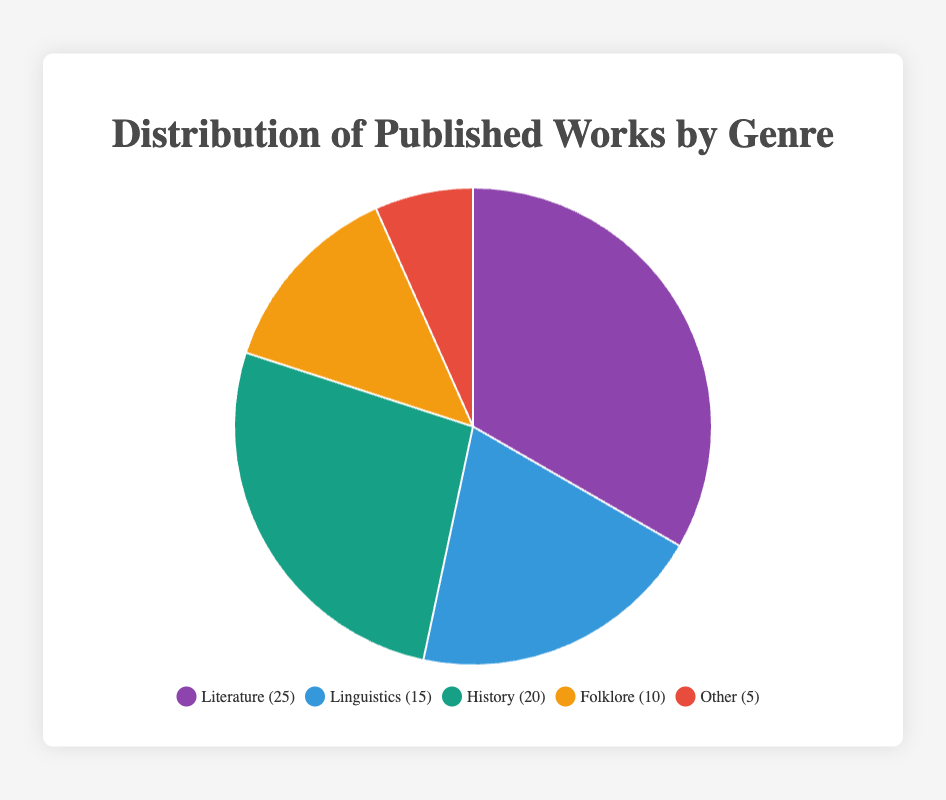Which genre has the largest number of published works? Look at the pie chart and identify the genre with the largest segment. The largest segment represents Literature with 25 published works.
Answer: Literature Which genre has a smaller proportion of published works: Folklore or Other? Compare the segments for Folklore and Other in the pie chart. The Folklore segment is larger than the Other segment (10 vs. 5 published works).
Answer: Other What is the total number of published works? Sum all the published works: Literature (25) + Linguistics (15) + History (20) + Folklore (10) + Other (5). The total equals 75.
Answer: 75 How many more works are published in Literature compared to Linguistics? Subtract the number of works in Linguistics from those in Literature: 25 (Literature) - 15 (Linguistics) = 10.
Answer: 10 What percentage of the total published works does the Linguistics genre represent? First, find the total number of published works (75). Then calculate the percentage for Linguistics: (15/75) * 100% = 20%.
Answer: 20% What is the combined total of published works in History and Folklore? Add the number of published works in History (20) to those in Folklore (10). The combined total is 30.
Answer: 30 If the colors representing the genres are purple, blue, green, orange, and red in order, which color represents the History genre? According to the given order, purple is for Literature, blue is for Linguistics, green is for History, orange is for Folklore, and red is for Other. Thus, green represents History.
Answer: Green Which has a greater difference in published works: Literature to History or History to Other? Calculate the differences: Literature to History is 25 - 20 = 5, and History to Other is 20 - 5 = 15. The greater difference is between History and Other.
Answer: History to Other What fraction of the published works are in the Folklore genre? Divide the number of works in Folklore (10) by the total number of published works (75). This gives 10/75, which simplifies to 2/15.
Answer: 2/15 Is the number of published works in Literature more than the combined total of works in Linguistics and Other? Add the works in Linguistics (15) and Other (5): 15 + 5 = 20. Literature has 25 works, which is more than 20.
Answer: Yes 